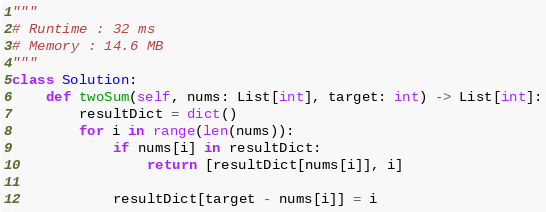<code> <loc_0><loc_0><loc_500><loc_500><_Python_>"""
# Runtime : 32 ms
# Memory : 14.6 MB
"""
class Solution:
    def twoSum(self, nums: List[int], target: int) -> List[int]:
        resultDict = dict()
        for i in range(len(nums)):
            if nums[i] in resultDict:
                return [resultDict[nums[i]], i]

            resultDict[target - nums[i]] = i</code> 